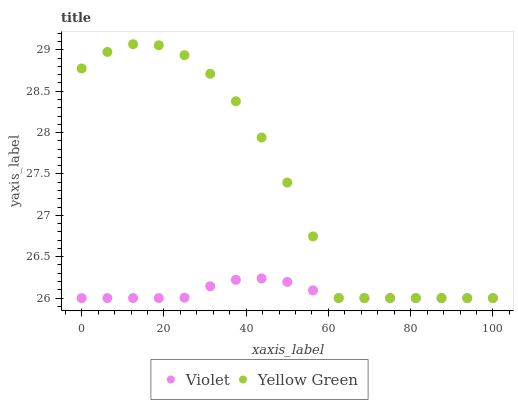Does Violet have the minimum area under the curve?
Answer yes or no. Yes. Does Yellow Green have the maximum area under the curve?
Answer yes or no. Yes. Does Violet have the maximum area under the curve?
Answer yes or no. No. Is Violet the smoothest?
Answer yes or no. Yes. Is Yellow Green the roughest?
Answer yes or no. Yes. Is Violet the roughest?
Answer yes or no. No. Does Yellow Green have the lowest value?
Answer yes or no. Yes. Does Yellow Green have the highest value?
Answer yes or no. Yes. Does Violet have the highest value?
Answer yes or no. No. Does Violet intersect Yellow Green?
Answer yes or no. Yes. Is Violet less than Yellow Green?
Answer yes or no. No. Is Violet greater than Yellow Green?
Answer yes or no. No. 